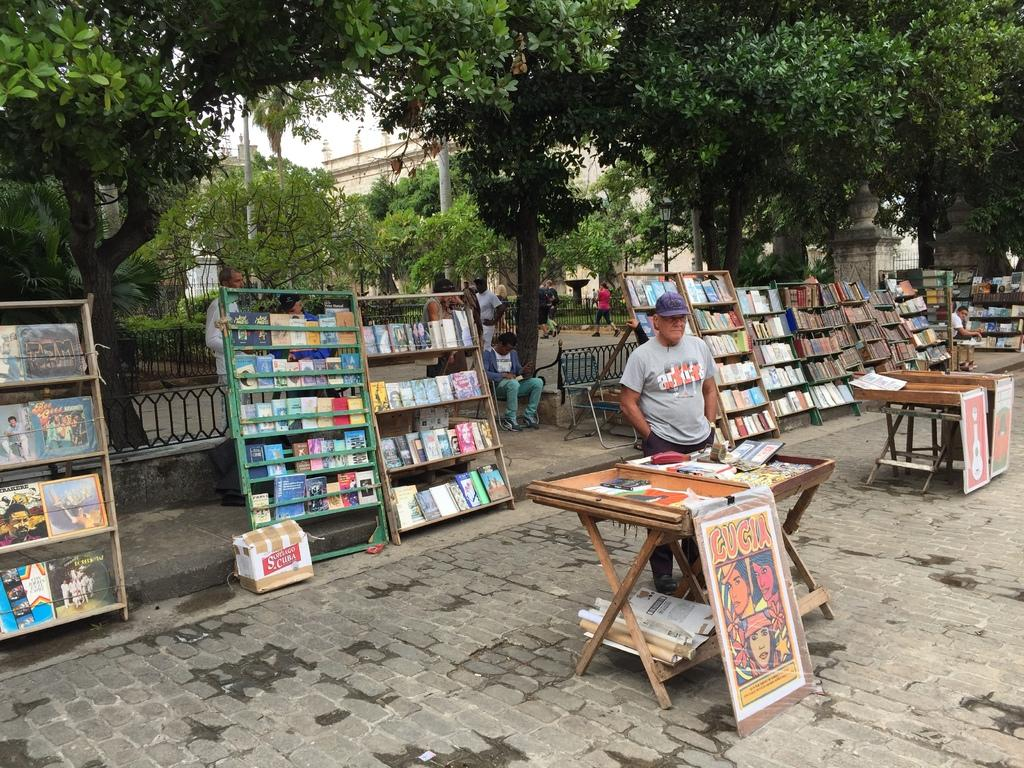What is the man in the image doing? The man is standing beside a table. What items can be seen on the table in the image? There are cards, papers, and banners on the table in the image. What can be seen in the background of the image? There are books in racks, benches, a tree, a building, a pole, and a fence in the background. What type of meal is the man sharing with his brother in the image? There is no mention of a meal or a brother in the image. The image only shows a man standing beside a table with cards, papers, and banners on it, along with various elements in the background. 